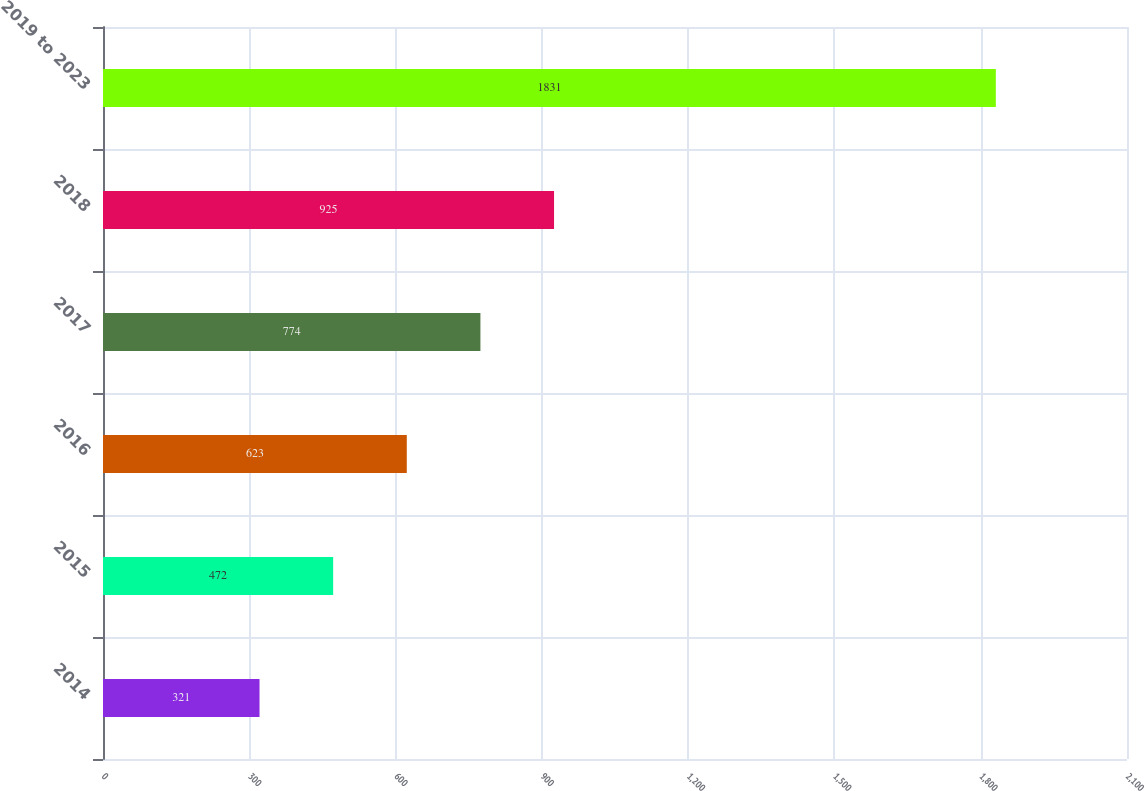Convert chart to OTSL. <chart><loc_0><loc_0><loc_500><loc_500><bar_chart><fcel>2014<fcel>2015<fcel>2016<fcel>2017<fcel>2018<fcel>2019 to 2023<nl><fcel>321<fcel>472<fcel>623<fcel>774<fcel>925<fcel>1831<nl></chart> 